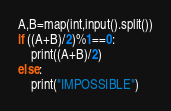<code> <loc_0><loc_0><loc_500><loc_500><_Python_>A,B=map(int,input().split())
if ((A+B)/2)%1==0:
    print((A+B)/2)
else:
    print("IMPOSSIBLE")</code> 